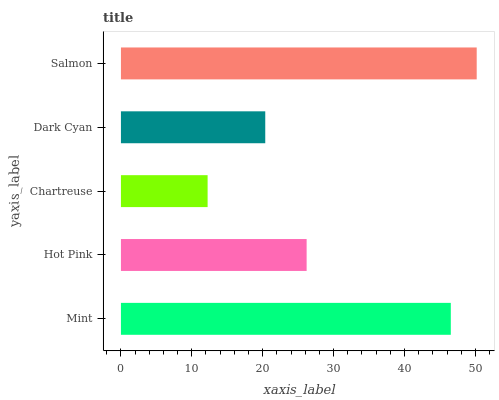Is Chartreuse the minimum?
Answer yes or no. Yes. Is Salmon the maximum?
Answer yes or no. Yes. Is Hot Pink the minimum?
Answer yes or no. No. Is Hot Pink the maximum?
Answer yes or no. No. Is Mint greater than Hot Pink?
Answer yes or no. Yes. Is Hot Pink less than Mint?
Answer yes or no. Yes. Is Hot Pink greater than Mint?
Answer yes or no. No. Is Mint less than Hot Pink?
Answer yes or no. No. Is Hot Pink the high median?
Answer yes or no. Yes. Is Hot Pink the low median?
Answer yes or no. Yes. Is Dark Cyan the high median?
Answer yes or no. No. Is Chartreuse the low median?
Answer yes or no. No. 